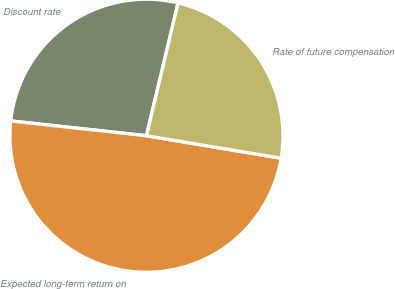Convert chart. <chart><loc_0><loc_0><loc_500><loc_500><pie_chart><fcel>Discount rate<fcel>Expected long-term return on<fcel>Rate of future compensation<nl><fcel>26.99%<fcel>49.1%<fcel>23.91%<nl></chart> 